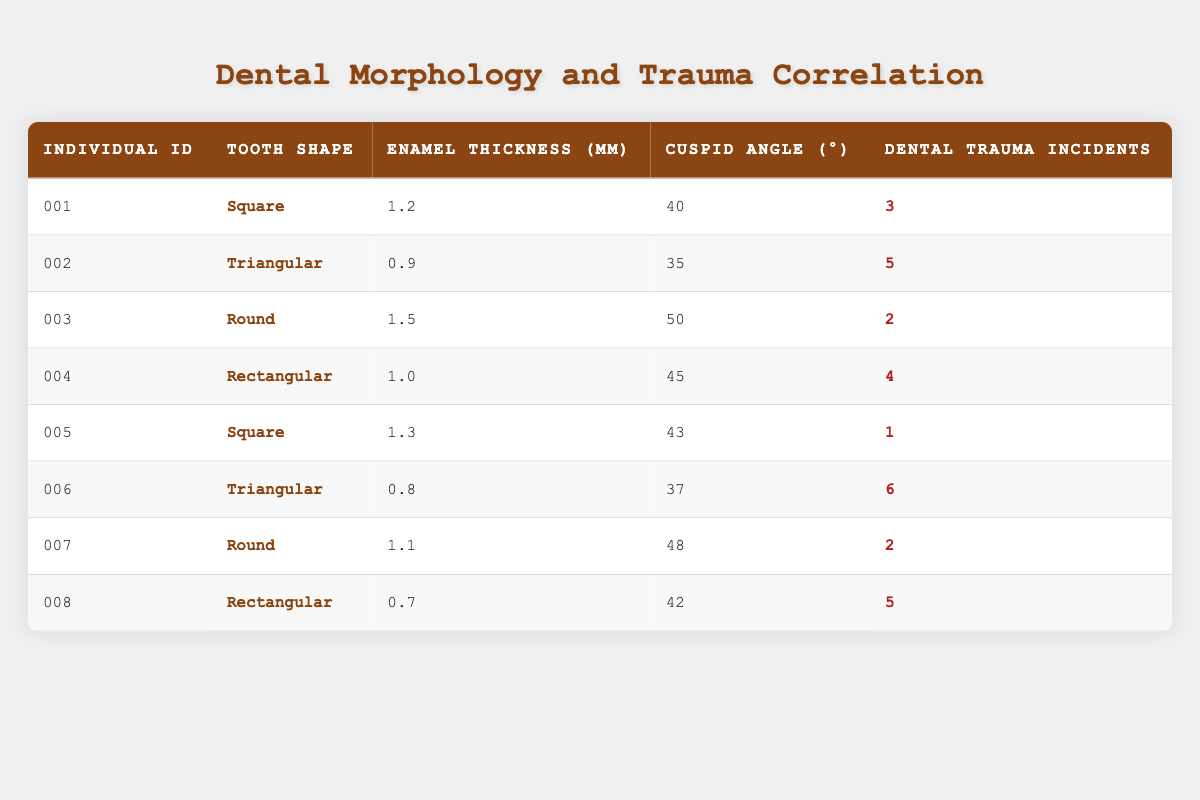What is the tooth shape for individual ID 004? The table shows that individual ID 004 has a tooth shape listed as "Rectangular."
Answer: Rectangular Which individual has the highest enamel thickness? By looking at the column for enamel thickness, individual ID 003 has a value of 1.5 mm, which is greater than all other individuals.
Answer: ID 003 What is the average number of dental trauma incidents for individuals with a Triangular tooth shape? There are two individuals with a Triangular tooth shape: ID 002 (5 incidents) and ID 006 (6 incidents). The sum of these incidents is 5 + 6 = 11. To find the average, we divide the total by the number of individuals, which is 11/2 = 5.5.
Answer: 5.5 Is there any individual with a Square tooth shape who has had more than 3 dental trauma incidents? Looking at the data, ID 001 (3 incidents) and ID 005 (1 incident) are the only individuals with a Square tooth shape, and neither exceeds 3 incidents. Therefore, the answer is no.
Answer: No Which tooth shape has the most dental trauma incidents on average? We have three categories of tooth shapes: Square, Triangular, Round, and Rectangular. First, we calculate the sum of incidents for each shape: Square (3 + 1 = 4, 2 individuals), Triangular (5 + 6 = 11, 2 individuals), Round (2 + 2 = 4, 2 individuals), and Rectangular (4 + 5 = 9, 2 individuals). The averages for each shape are: Square (4/2 = 2), Triangular (11/2 = 5.5), Round (4/2 = 2), and Rectangular (9/2 = 4.5). Triangular has the highest average at 5.5 incidents.
Answer: Triangular 